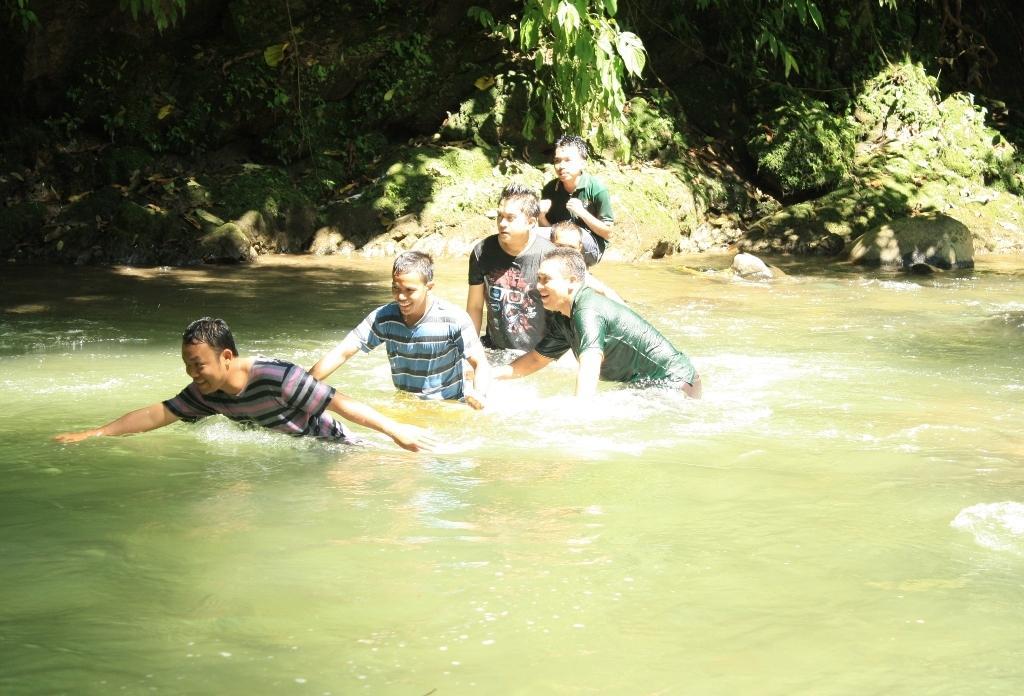Describe this image in one or two sentences. In the image I can see some people in the pond and behind there are some trees, plants and rocks. 